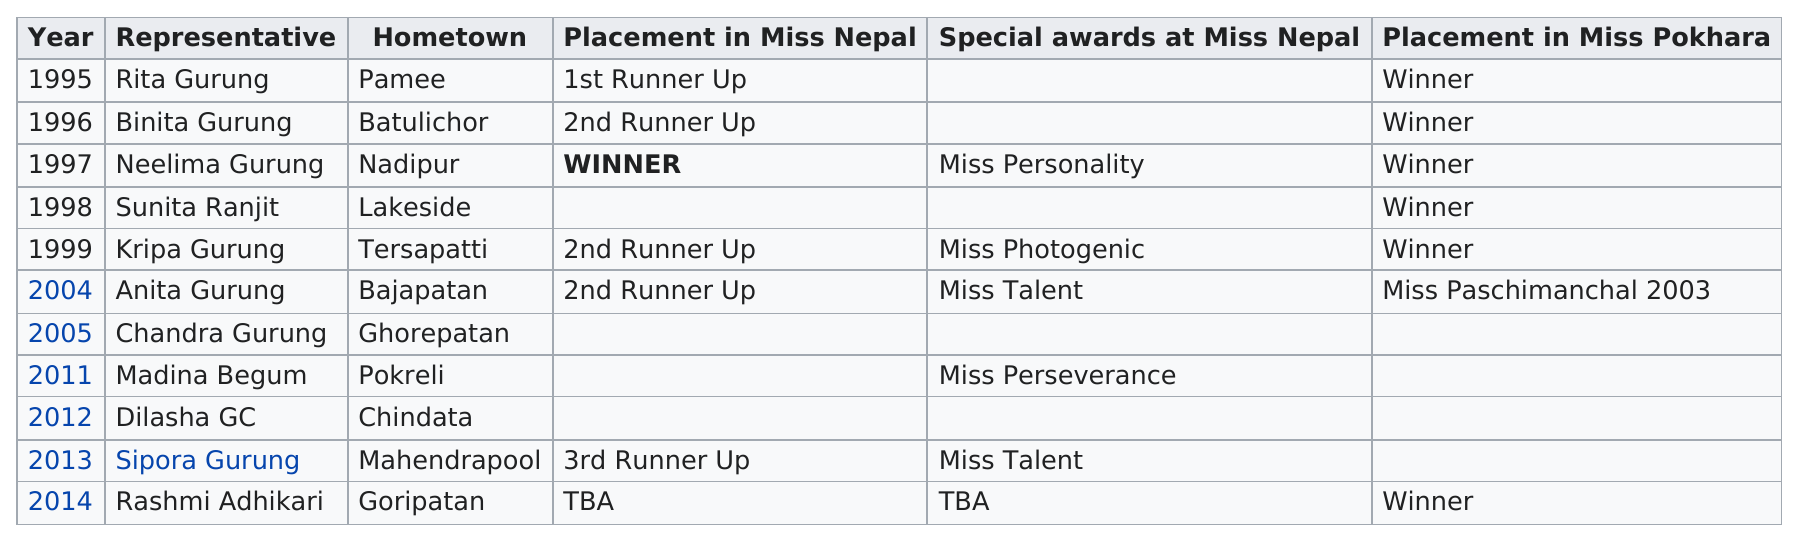Indicate a few pertinent items in this graphic. Miss Pokhara last won the Miss Nepal award in 1997. In 1998, the year after 1997. What hometown comes before Pokreli? Ghorepatan does. Rashmi Adhikari was the last winner of the Miss Pokhara pageant. Madina Begum was the only Miss Nepal representative who won a special award but did not place at the Miss Nepal competition. 